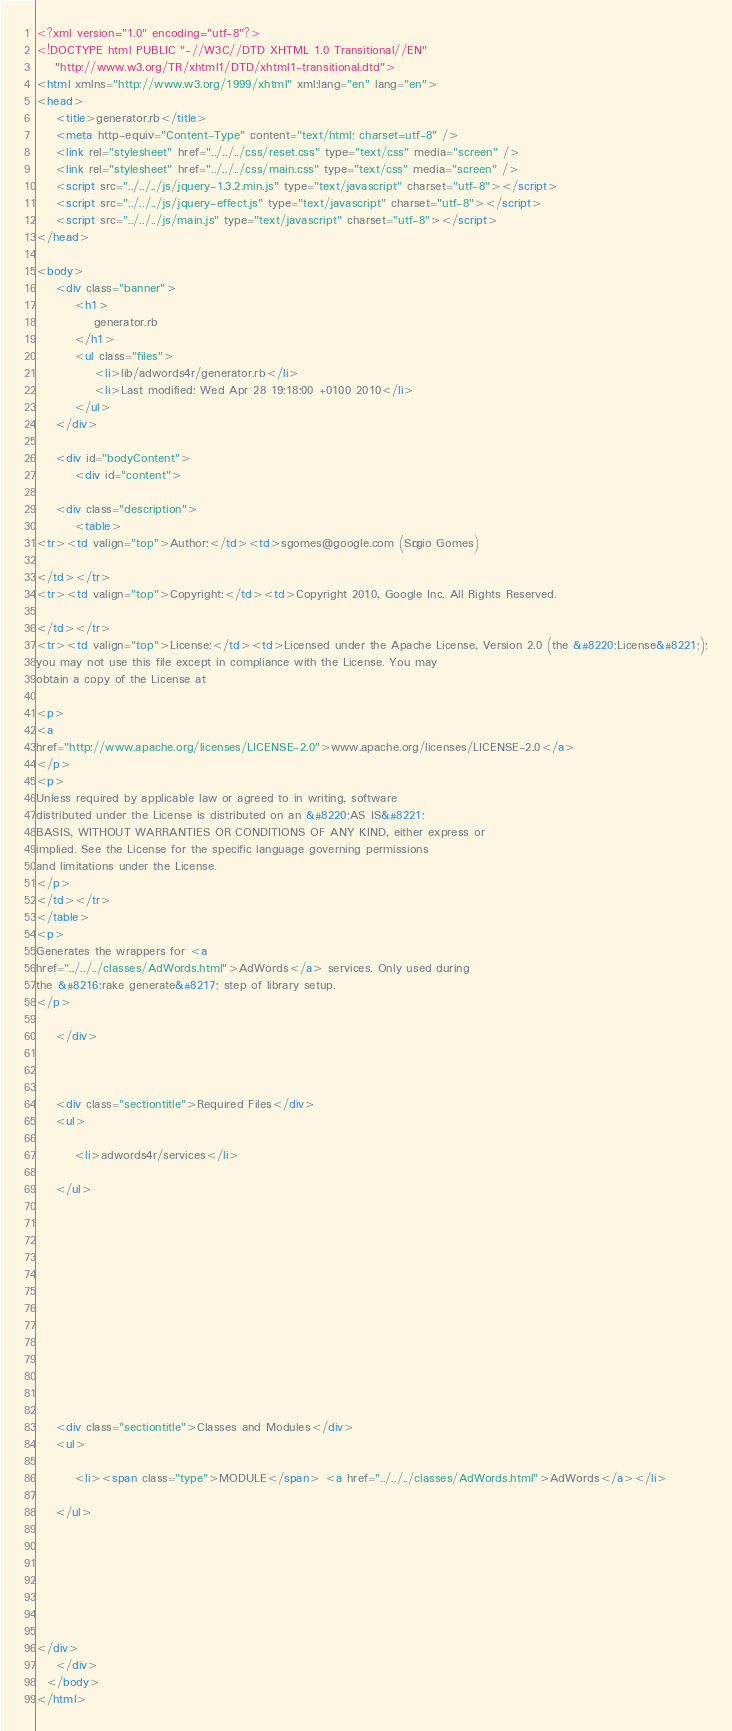Convert code to text. <code><loc_0><loc_0><loc_500><loc_500><_HTML_><?xml version="1.0" encoding="utf-8"?>
<!DOCTYPE html PUBLIC "-//W3C//DTD XHTML 1.0 Transitional//EN"
    "http://www.w3.org/TR/xhtml1/DTD/xhtml1-transitional.dtd">
<html xmlns="http://www.w3.org/1999/xhtml" xml:lang="en" lang="en">
<head>
    <title>generator.rb</title>
    <meta http-equiv="Content-Type" content="text/html; charset=utf-8" />
    <link rel="stylesheet" href="../../../css/reset.css" type="text/css" media="screen" />
    <link rel="stylesheet" href="../../../css/main.css" type="text/css" media="screen" />
    <script src="../../../js/jquery-1.3.2.min.js" type="text/javascript" charset="utf-8"></script>
    <script src="../../../js/jquery-effect.js" type="text/javascript" charset="utf-8"></script>
    <script src="../../../js/main.js" type="text/javascript" charset="utf-8"></script>
</head>

<body>     
    <div class="banner">
        <h1>
            generator.rb
        </h1>
        <ul class="files">
            <li>lib/adwords4r/generator.rb</li>
            <li>Last modified: Wed Apr 28 19:18:00 +0100 2010</li>
        </ul>
    </div>

    <div id="bodyContent">
        <div id="content">
    
    <div class="description">
        <table>
<tr><td valign="top">Author:</td><td>sgomes@google.com (Sérgio Gomes)

</td></tr>
<tr><td valign="top">Copyright:</td><td>Copyright 2010, Google Inc. All Rights Reserved.

</td></tr>
<tr><td valign="top">License:</td><td>Licensed under the Apache License, Version 2.0 (the &#8220;License&#8221;);
you may not use this file except in compliance with the License. You may
obtain a copy of the License at

<p>
<a
href="http://www.apache.org/licenses/LICENSE-2.0">www.apache.org/licenses/LICENSE-2.0</a>
</p>
<p>
Unless required by applicable law or agreed to in writing, software
distributed under the License is distributed on an &#8220;AS IS&#8221;
BASIS, WITHOUT WARRANTIES OR CONDITIONS OF ANY KIND, either express or
implied. See the License for the specific language governing permissions
and limitations under the License.
</p>
</td></tr>
</table>
<p>
Generates the wrappers for <a
href="../../../classes/AdWords.html">AdWords</a> services. Only used during
the &#8216;rake generate&#8217; step of library setup.
</p>

    </div>
    

    
    <div class="sectiontitle">Required Files</div>
    <ul>
        
        <li>adwords4r/services</li>
        
    </ul>
    

    
    

    
    

    

    

    
    <div class="sectiontitle">Classes and Modules</div>
    <ul>
        
        <li><span class="type">MODULE</span> <a href="../../../classes/AdWords.html">AdWords</a></li>
        
    </ul>
    

    

    

    
</div>
    </div>
  </body>
</html></code> 